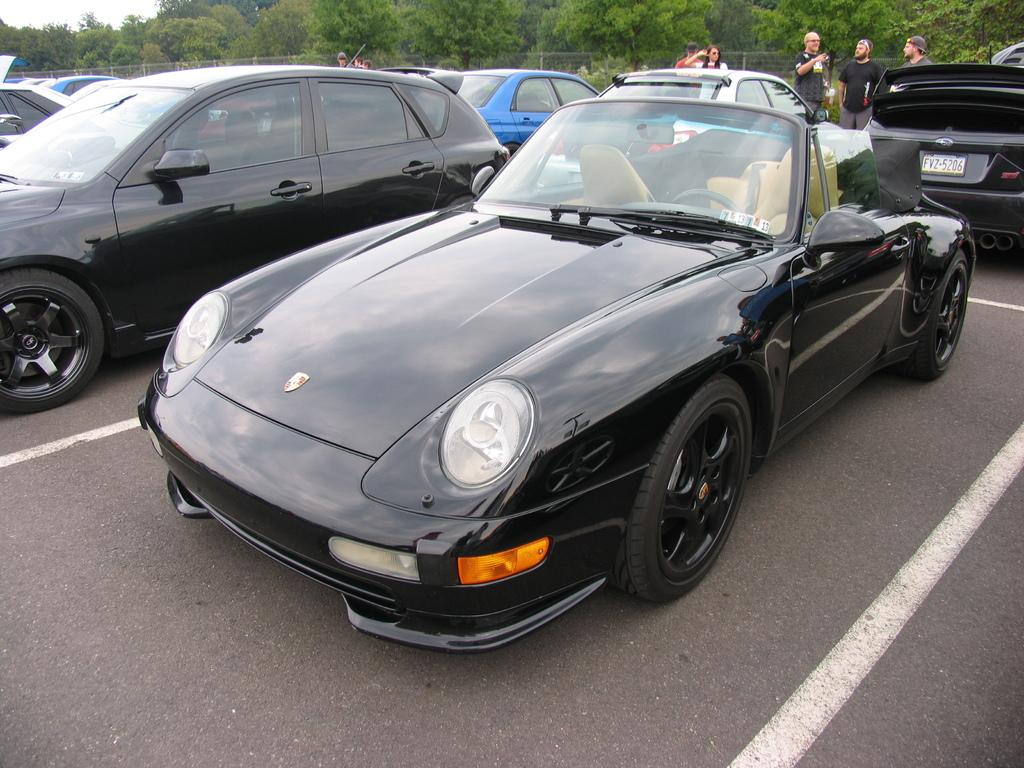What type of vehicles are in the image? There are different models of cars in the image. Where are the cars located? The cars are on the road. Can you describe the people in the image? There are people behind the cars. What can be seen in the background of the image? There are trees visible at the top of the image. What type of bed can be seen in the image? There is no bed present in the image. Can you tell me how many toothbrushes are visible in the image? There are no toothbrushes present in the image. 